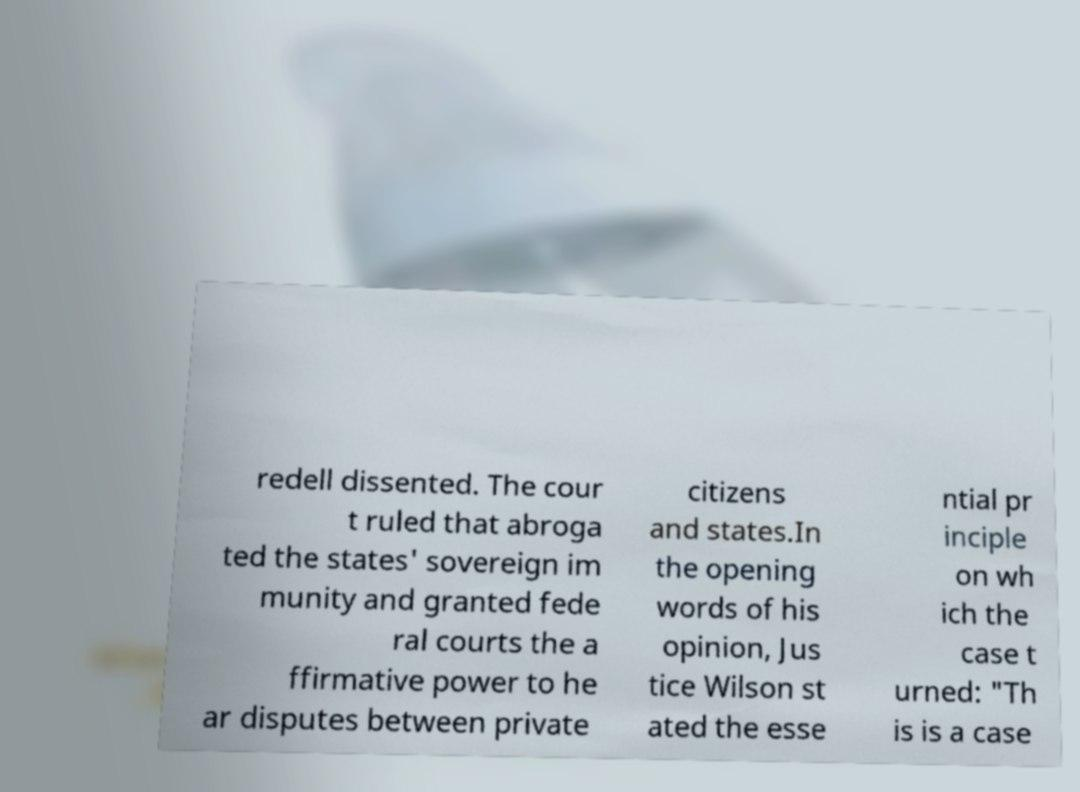Can you read and provide the text displayed in the image?This photo seems to have some interesting text. Can you extract and type it out for me? redell dissented. The cour t ruled that abroga ted the states' sovereign im munity and granted fede ral courts the a ffirmative power to he ar disputes between private citizens and states.In the opening words of his opinion, Jus tice Wilson st ated the esse ntial pr inciple on wh ich the case t urned: "Th is is a case 